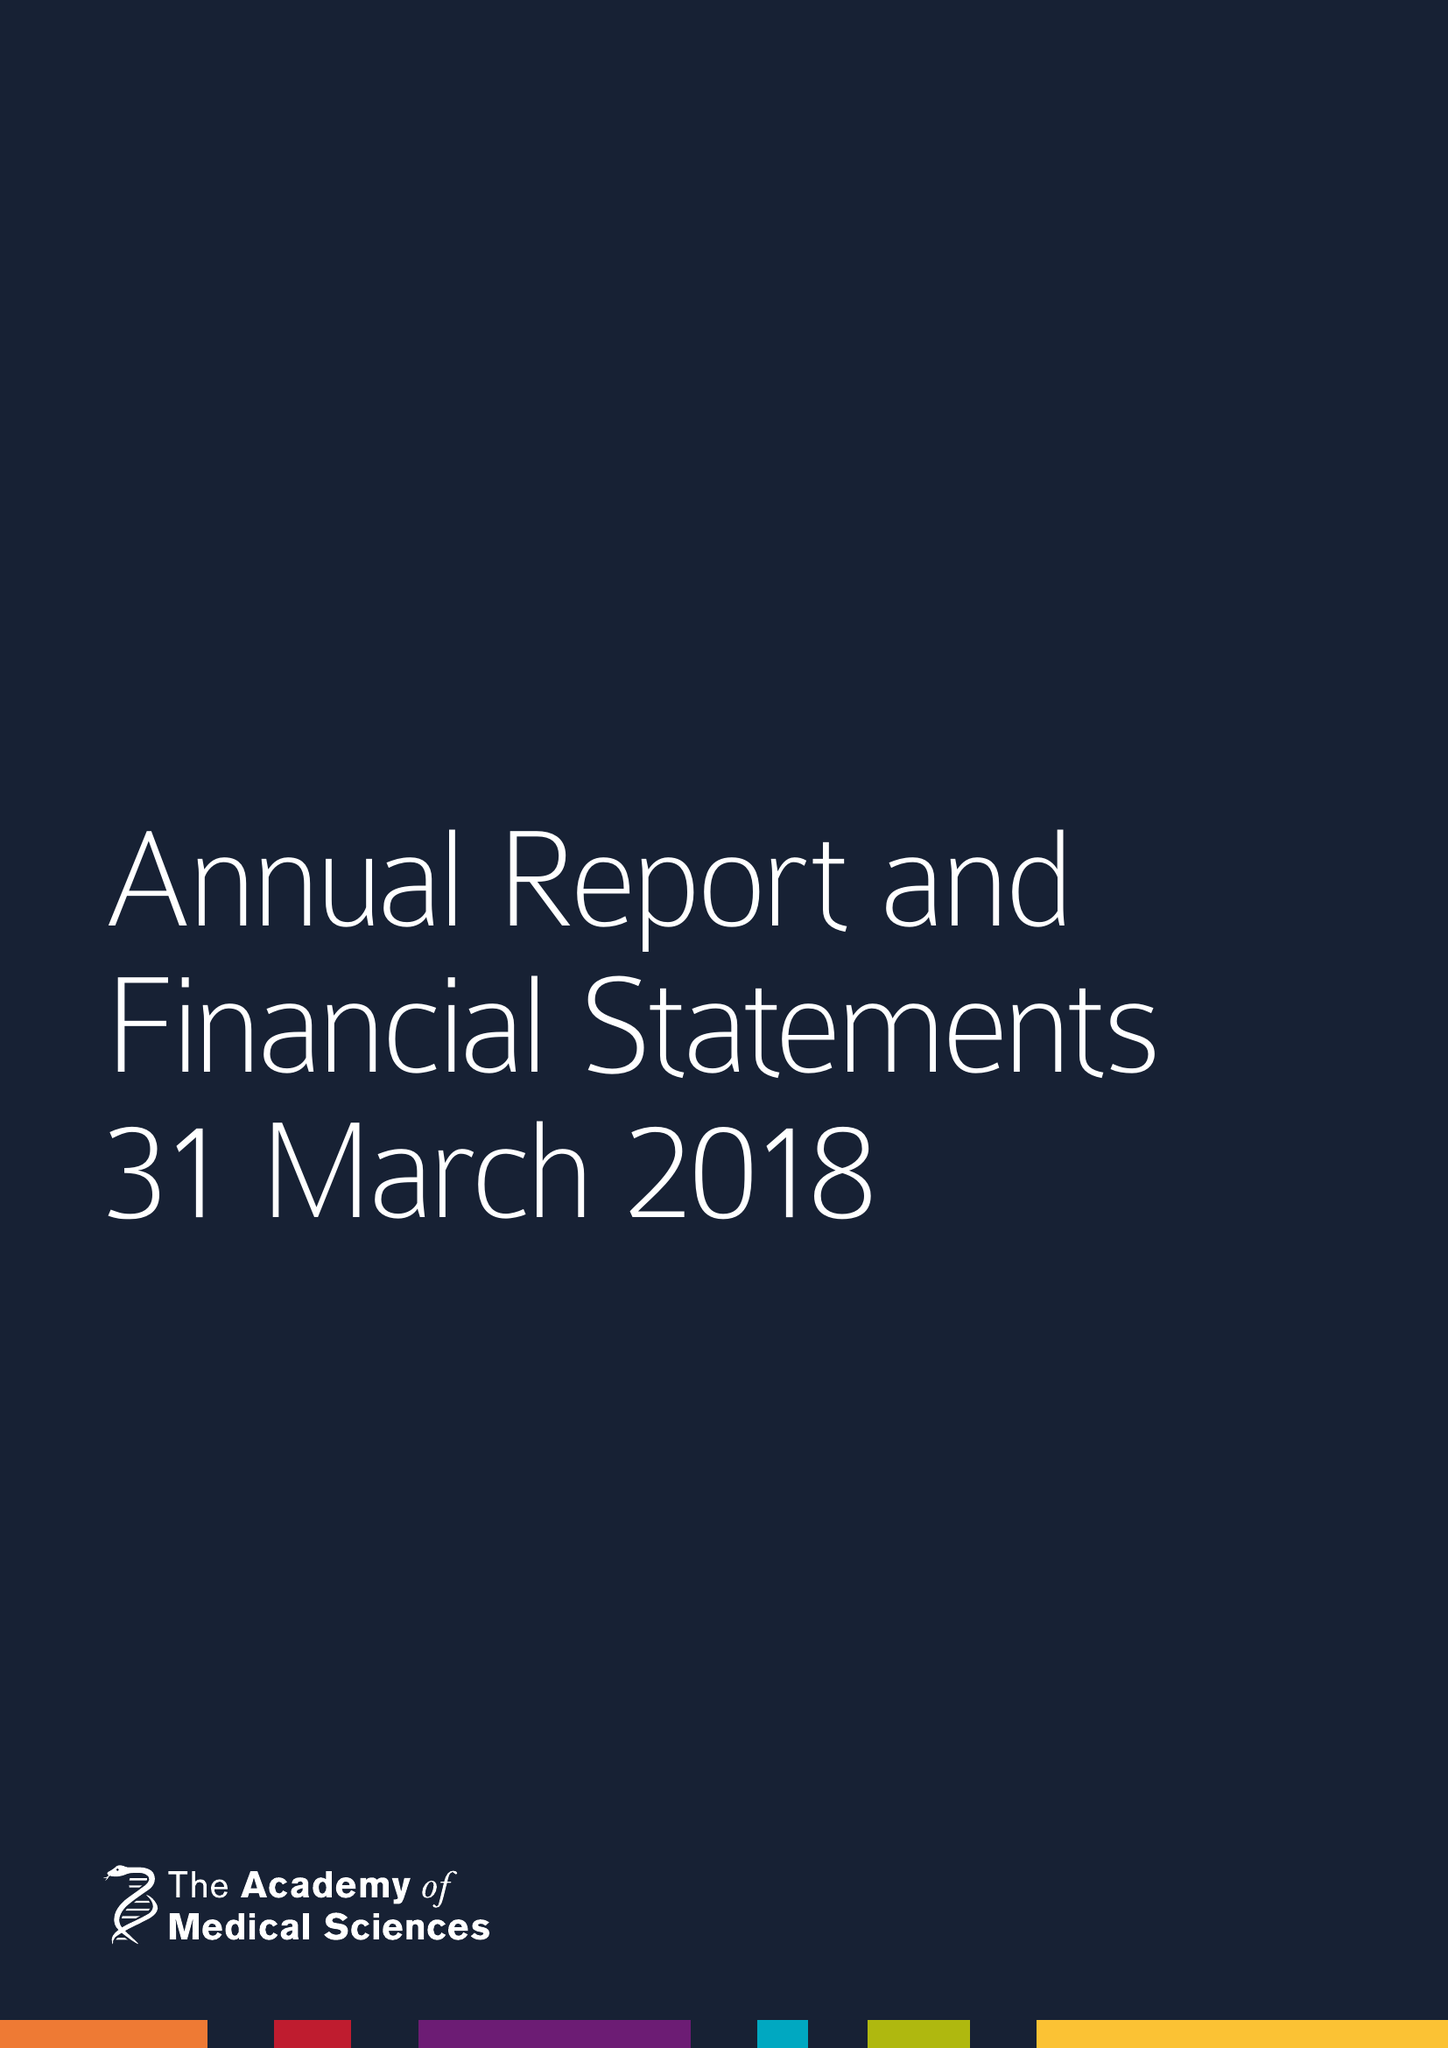What is the value for the address__street_line?
Answer the question using a single word or phrase. 41 PORTLAND PLACE 